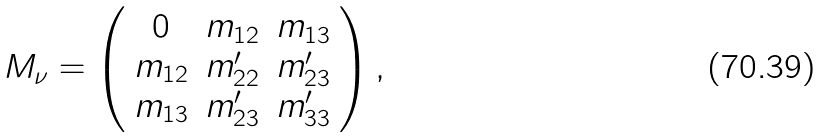Convert formula to latex. <formula><loc_0><loc_0><loc_500><loc_500>M _ { \nu } = \left ( \begin{array} { c c c } 0 & m _ { 1 2 } & m _ { 1 3 } \\ m _ { 1 2 } & m _ { 2 2 } ^ { \prime } & m _ { 2 3 } ^ { \prime } \\ m _ { 1 3 } & m _ { 2 3 } ^ { \prime } & m _ { 3 3 } ^ { \prime } \\ \end{array} \right ) ,</formula> 